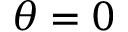<formula> <loc_0><loc_0><loc_500><loc_500>\theta = 0</formula> 